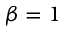Convert formula to latex. <formula><loc_0><loc_0><loc_500><loc_500>\beta = 1</formula> 